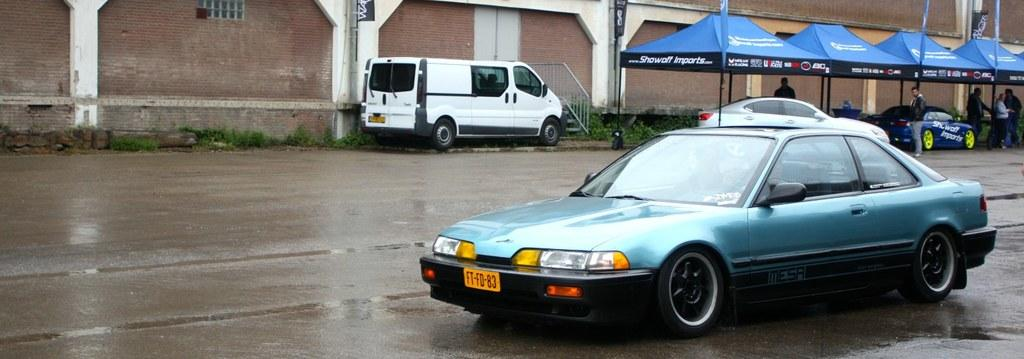What can be seen in the image? There are vehicles in the image. What is located at the top of the image? There is a wall at the top of the image. What is present in the top right of the image? There are tents and persons in the top right of the image. How many ladybugs are crawling on the vehicles in the image? There are no ladybugs visible in the image. What type of loaf is being used as a pillow by the persons in the top right of the image? There is no loaf visible in the image, and the persons are not using any loaf as a pillow. 